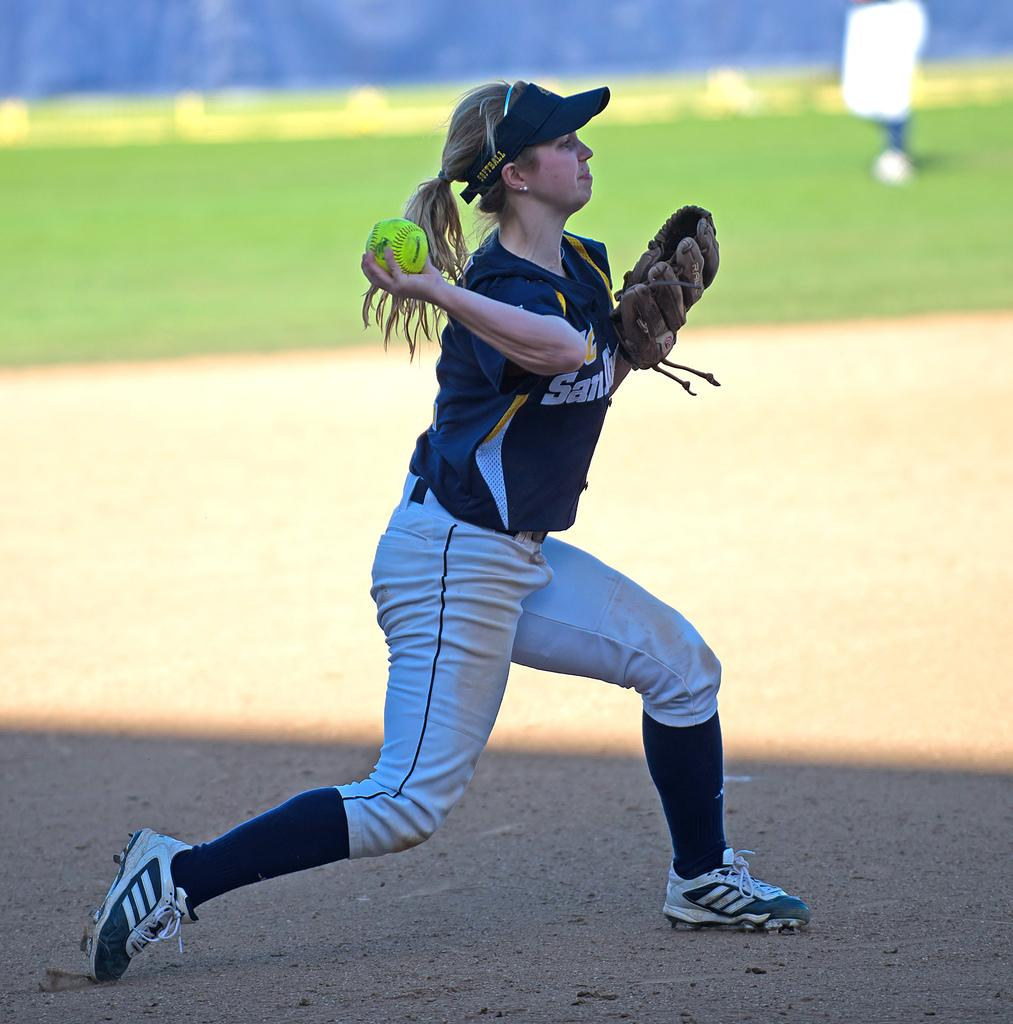<image>
Give a short and clear explanation of the subsequent image. The player is playing on the team from San Diego 